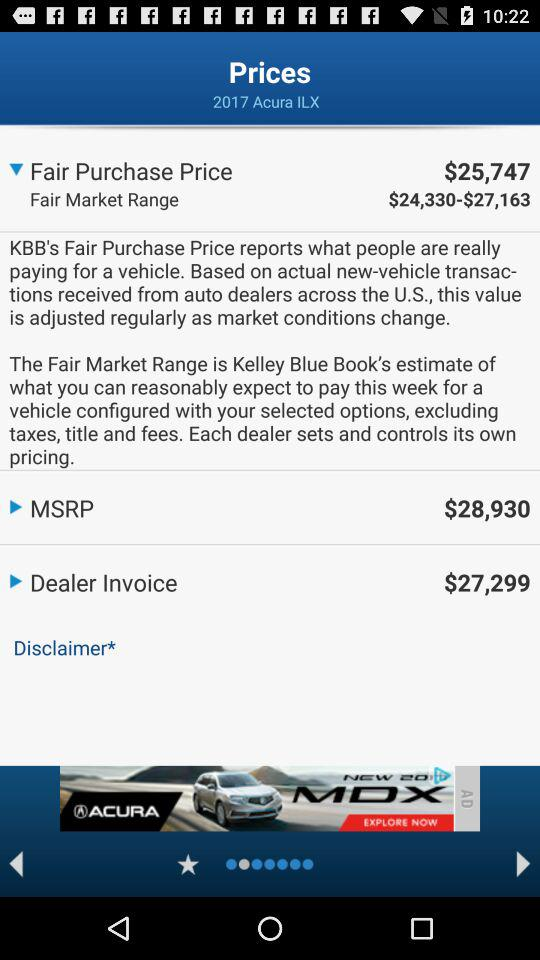What is the fair purchase price? The fair purchase price is $25,747. 